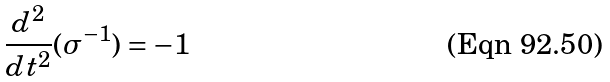<formula> <loc_0><loc_0><loc_500><loc_500>\frac { d ^ { 2 } } { d t ^ { 2 } } ( \sigma ^ { - 1 } ) = - 1</formula> 